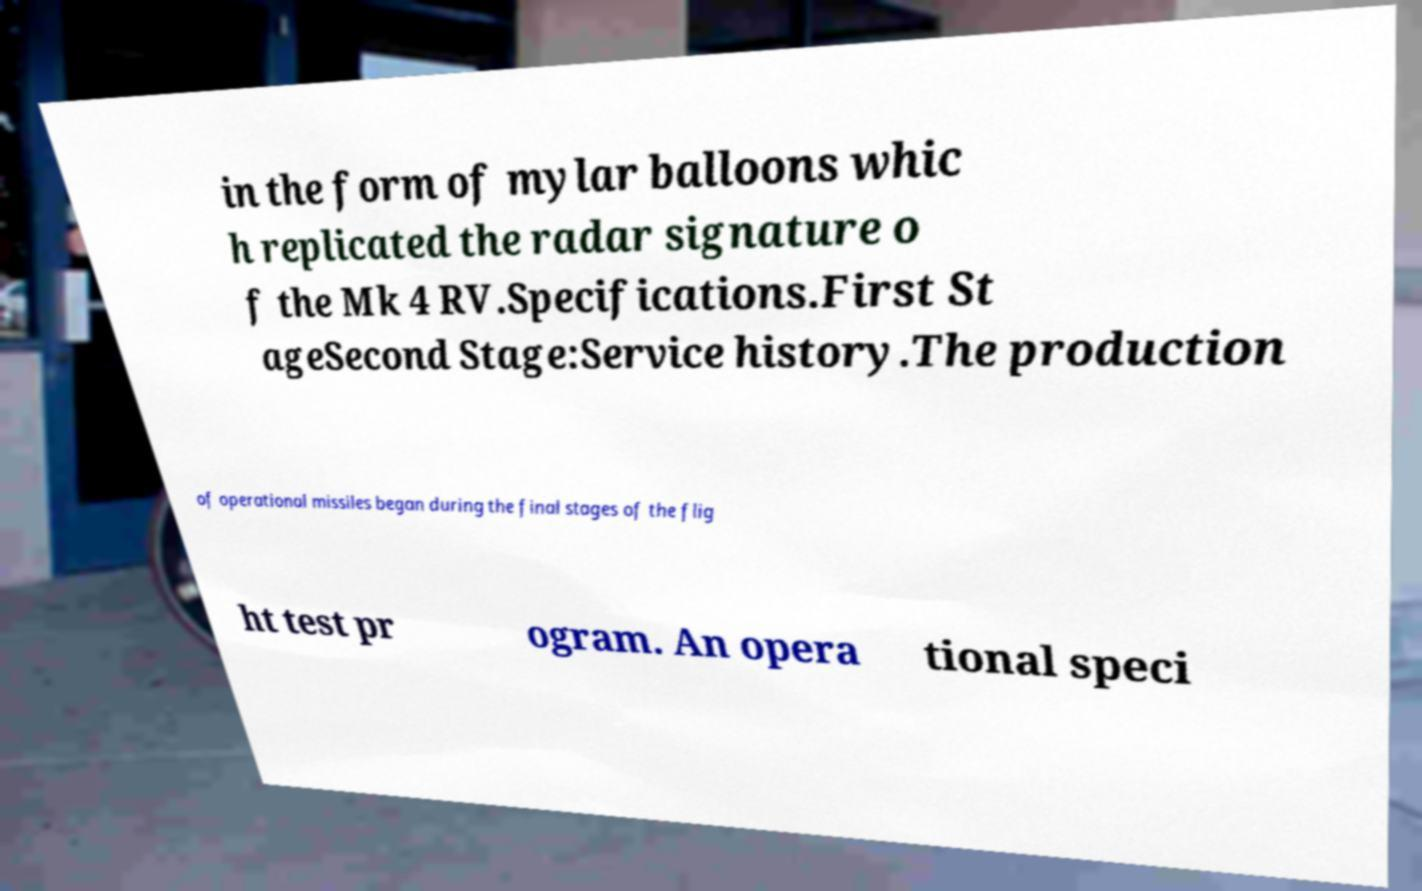Please identify and transcribe the text found in this image. in the form of mylar balloons whic h replicated the radar signature o f the Mk 4 RV.Specifications.First St ageSecond Stage:Service history.The production of operational missiles began during the final stages of the flig ht test pr ogram. An opera tional speci 